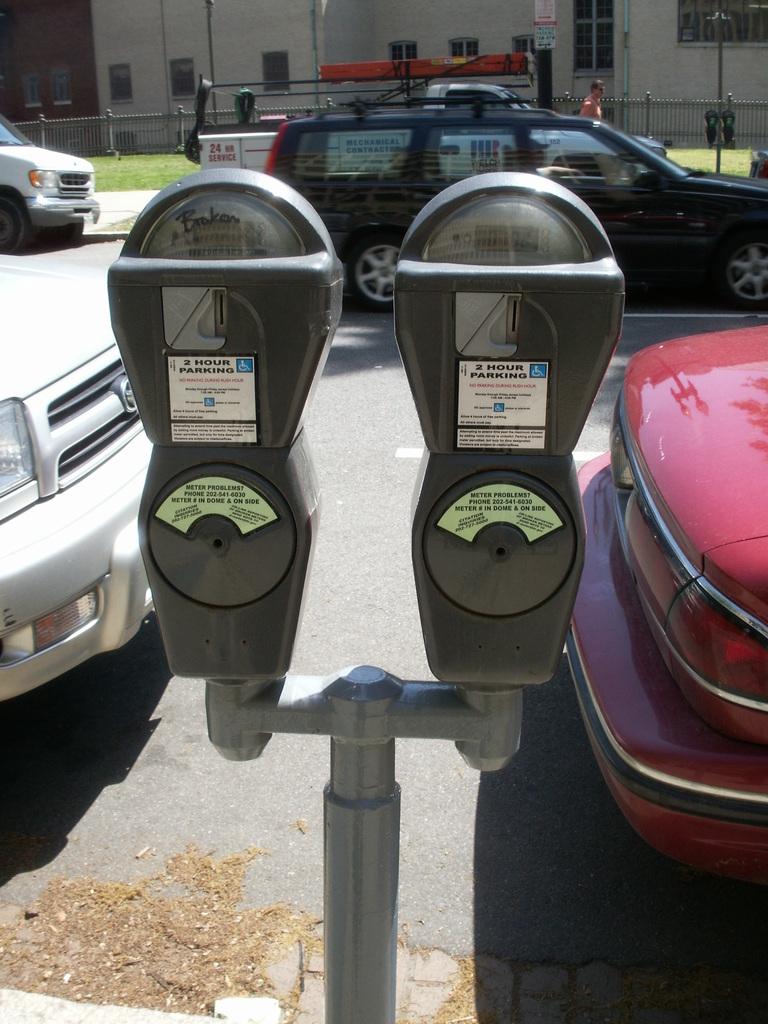For how many consecutive hours is parking permitted?
Make the answer very short. 2. 